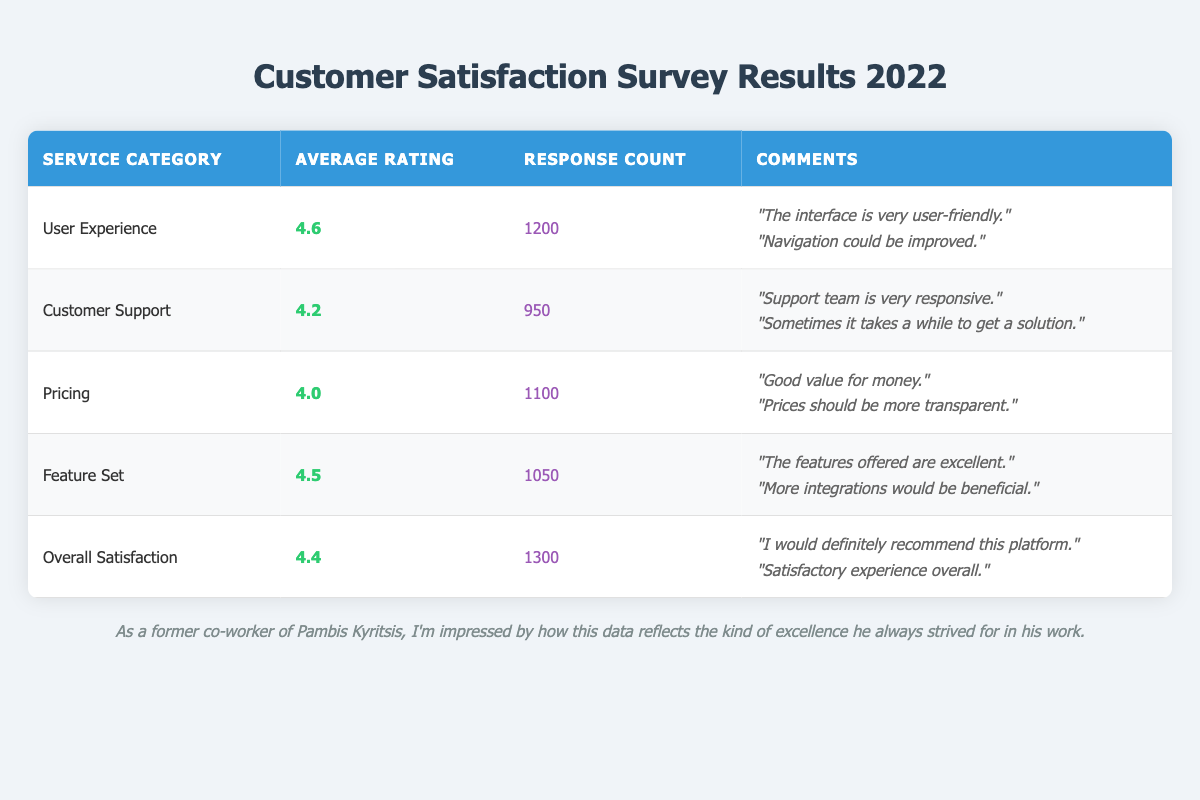What is the average rating for the "User Experience" category? The average rating for the "User Experience" category is listed directly in the table as 4.6.
Answer: 4.6 How many responses were collected for the "Customer Support" category? The number of responses for "Customer Support" is shown in the table as 950.
Answer: 950 Which service category received the highest average rating? By comparing the average ratings listed in the table, "User Experience" has the highest rating at 4.6.
Answer: User Experience What is the total number of responses for both "Pricing" and "Feature Set" categories combined? The response count for "Pricing" is 1100 and for "Feature Set" is 1050. Adding these values gives 1100 + 1050 = 2150.
Answer: 2150 Is the average rating for "Customer Support" greater than or equal to 4.0? The average rating for "Customer Support" is 4.2, which is indeed greater than 4.0.
Answer: Yes What is the difference in average ratings between "Overall Satisfaction" and "Feature Set"? "Overall Satisfaction" has an average rating of 4.4 and "Feature Set" has 4.5. The difference is 4.5 - 4.4 = 0.1.
Answer: 0.1 How many more responses were received for the "Overall Satisfaction" category compared to the "Customer Support" category? "Overall Satisfaction" received 1300 responses and "Customer Support" received 950 responses. The difference is 1300 - 950 = 350.
Answer: 350 What percentage of total responses does the "User Experience" category represent if the total responses across all categories is calculated as 5200? The "User Experience" has 1200 responses. The percentage calculated is (1200 / 5200) * 100 = 23.08%.
Answer: 23.08% Which category has the lowest average rating and what is that rating? The lowest average rating is for the "Pricing" category, which is listed as 4.0 in the table.
Answer: 4.0 How many comments mention a need for improvement in the "User Experience"? In the "User Experience" comments, one comment mentions "Navigation could be improved," indicating one mention of improvement needed.
Answer: 1 